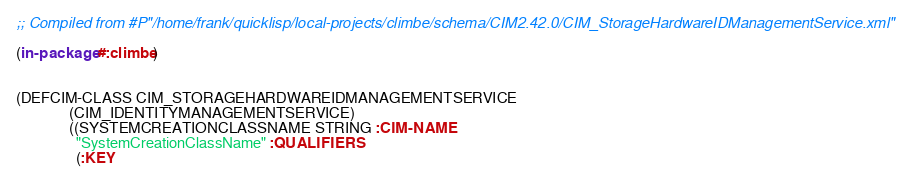<code> <loc_0><loc_0><loc_500><loc_500><_Lisp_>
;; Compiled from #P"/home/frank/quicklisp/local-projects/climbe/schema/CIM2.42.0/CIM_StorageHardwareIDManagementService.xml"

(in-package #:climbe)


(DEFCIM-CLASS CIM_STORAGEHARDWAREIDMANAGEMENTSERVICE
              (CIM_IDENTITYMANAGEMENTSERVICE)
              ((SYSTEMCREATIONCLASSNAME STRING :CIM-NAME
                "SystemCreationClassName" :QUALIFIERS
                (:KEY</code> 